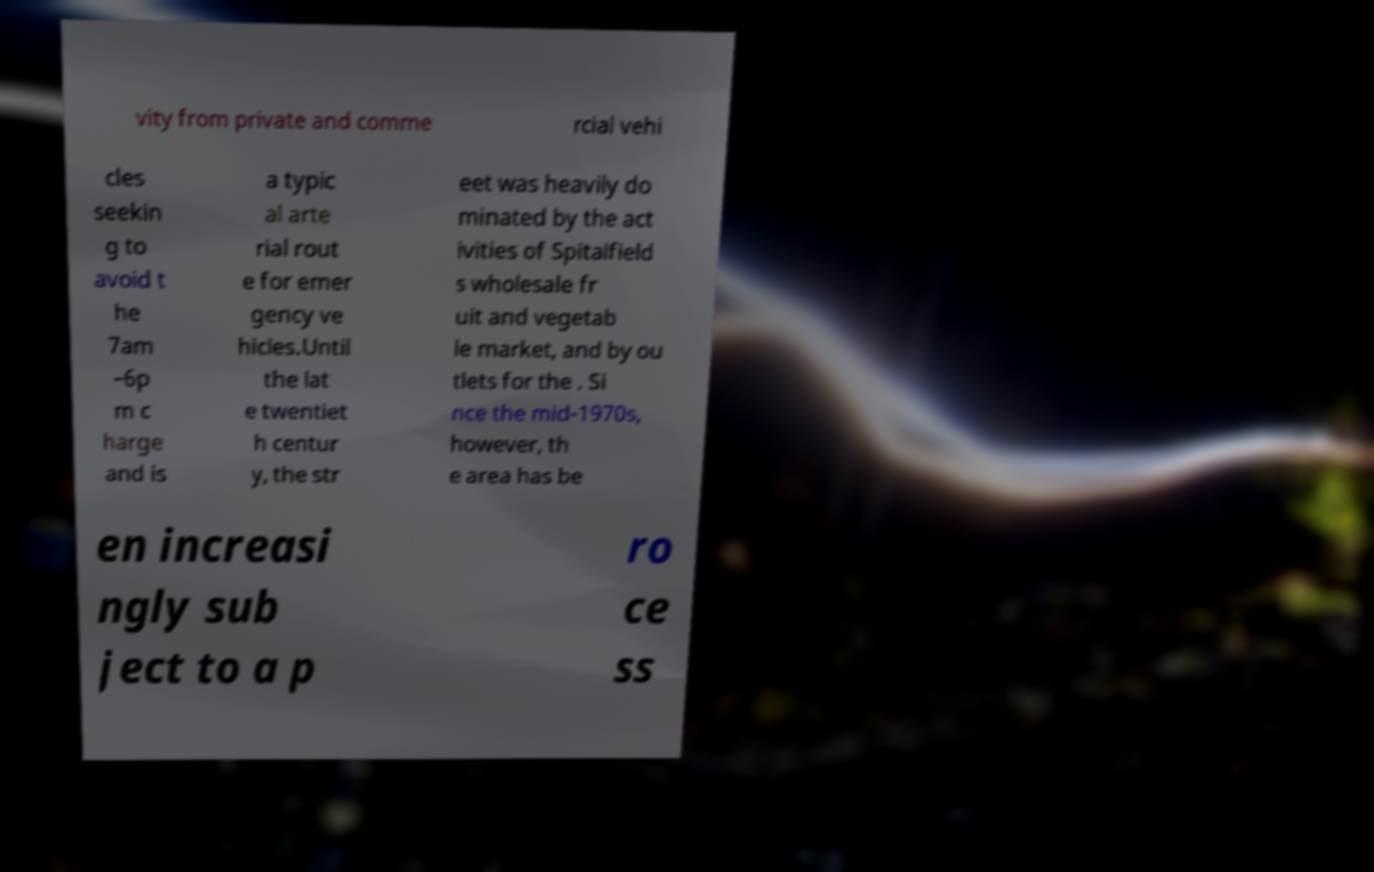Please identify and transcribe the text found in this image. vity from private and comme rcial vehi cles seekin g to avoid t he 7am –6p m c harge and is a typic al arte rial rout e for emer gency ve hicles.Until the lat e twentiet h centur y, the str eet was heavily do minated by the act ivities of Spitalfield s wholesale fr uit and vegetab le market, and by ou tlets for the . Si nce the mid-1970s, however, th e area has be en increasi ngly sub ject to a p ro ce ss 